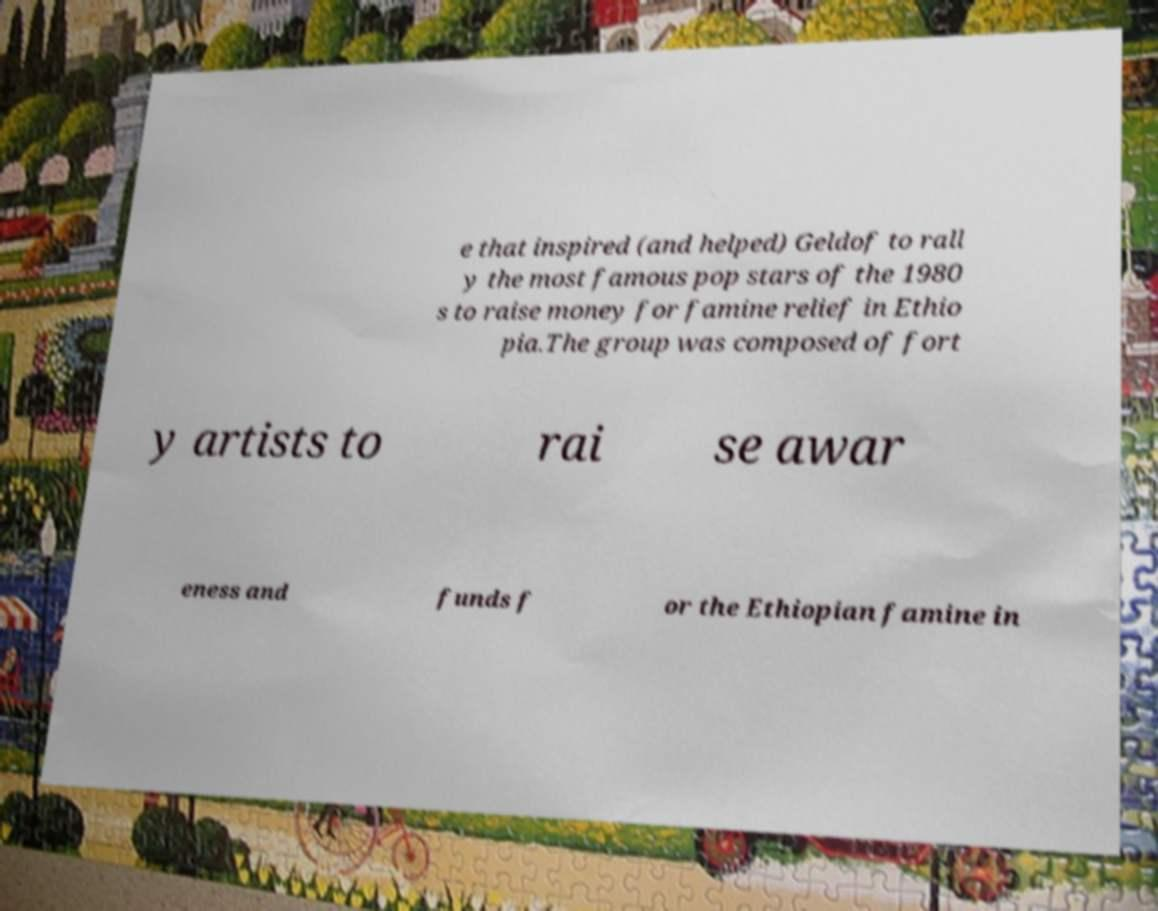Please identify and transcribe the text found in this image. e that inspired (and helped) Geldof to rall y the most famous pop stars of the 1980 s to raise money for famine relief in Ethio pia.The group was composed of fort y artists to rai se awar eness and funds f or the Ethiopian famine in 